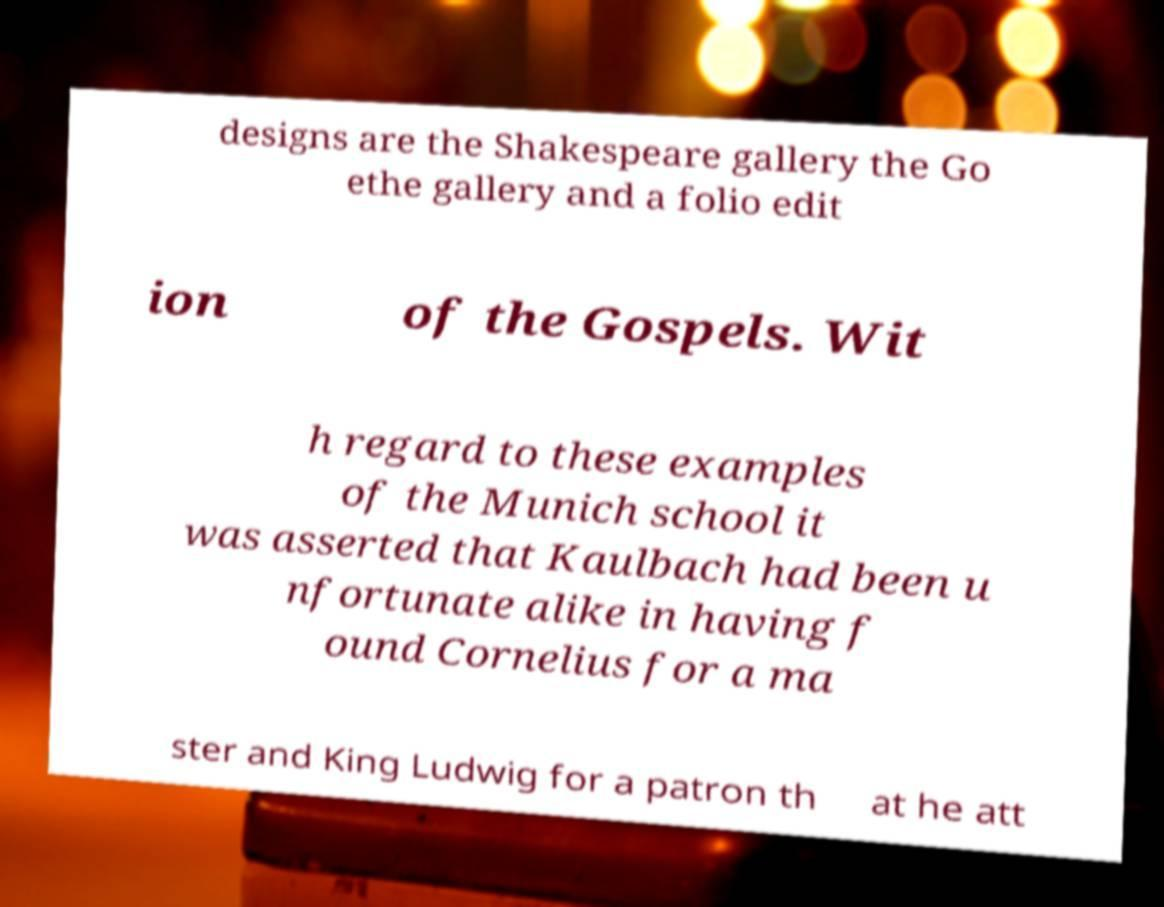I need the written content from this picture converted into text. Can you do that? designs are the Shakespeare gallery the Go ethe gallery and a folio edit ion of the Gospels. Wit h regard to these examples of the Munich school it was asserted that Kaulbach had been u nfortunate alike in having f ound Cornelius for a ma ster and King Ludwig for a patron th at he att 